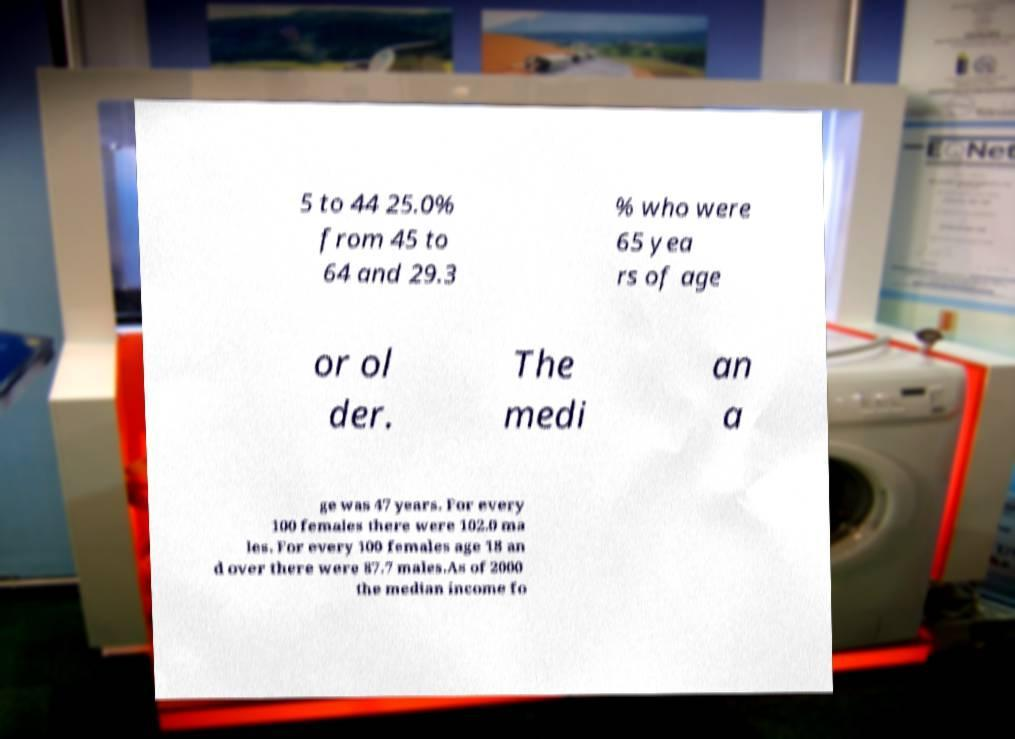Can you read and provide the text displayed in the image?This photo seems to have some interesting text. Can you extract and type it out for me? 5 to 44 25.0% from 45 to 64 and 29.3 % who were 65 yea rs of age or ol der. The medi an a ge was 47 years. For every 100 females there were 102.0 ma les. For every 100 females age 18 an d over there were 87.7 males.As of 2000 the median income fo 